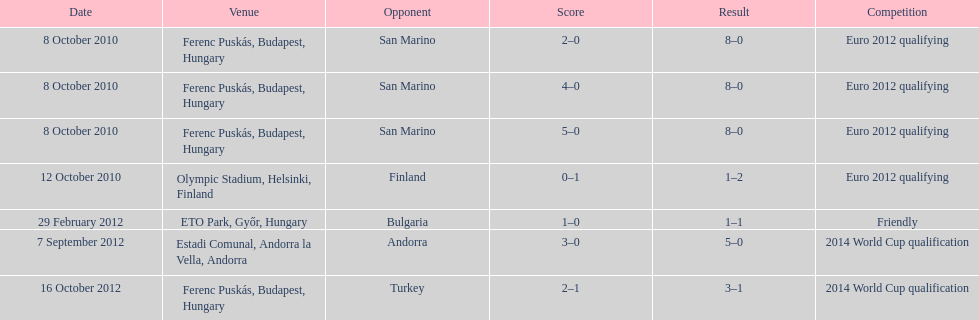What was the year when szalai netted his first goal internationally? 2010. 